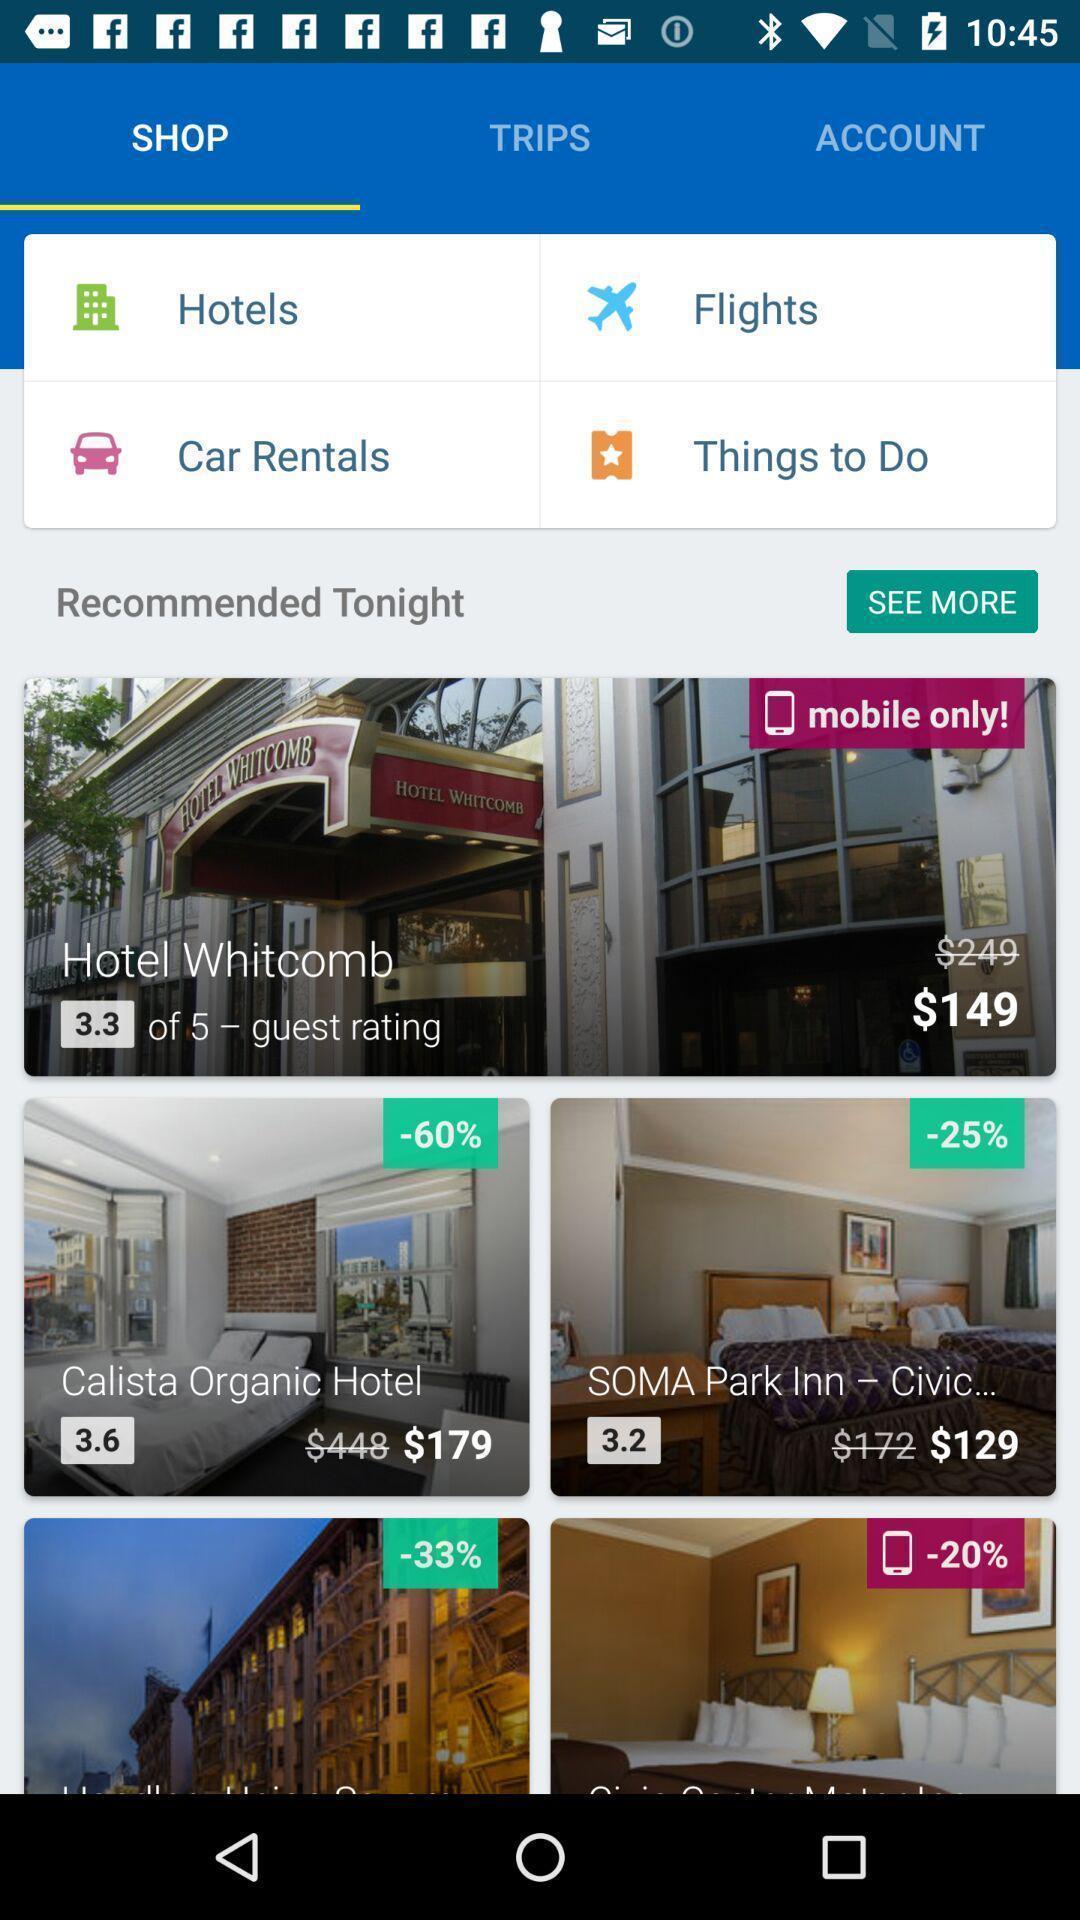What is the overall content of this screenshot? Page showing hotels and flights available for booking. 